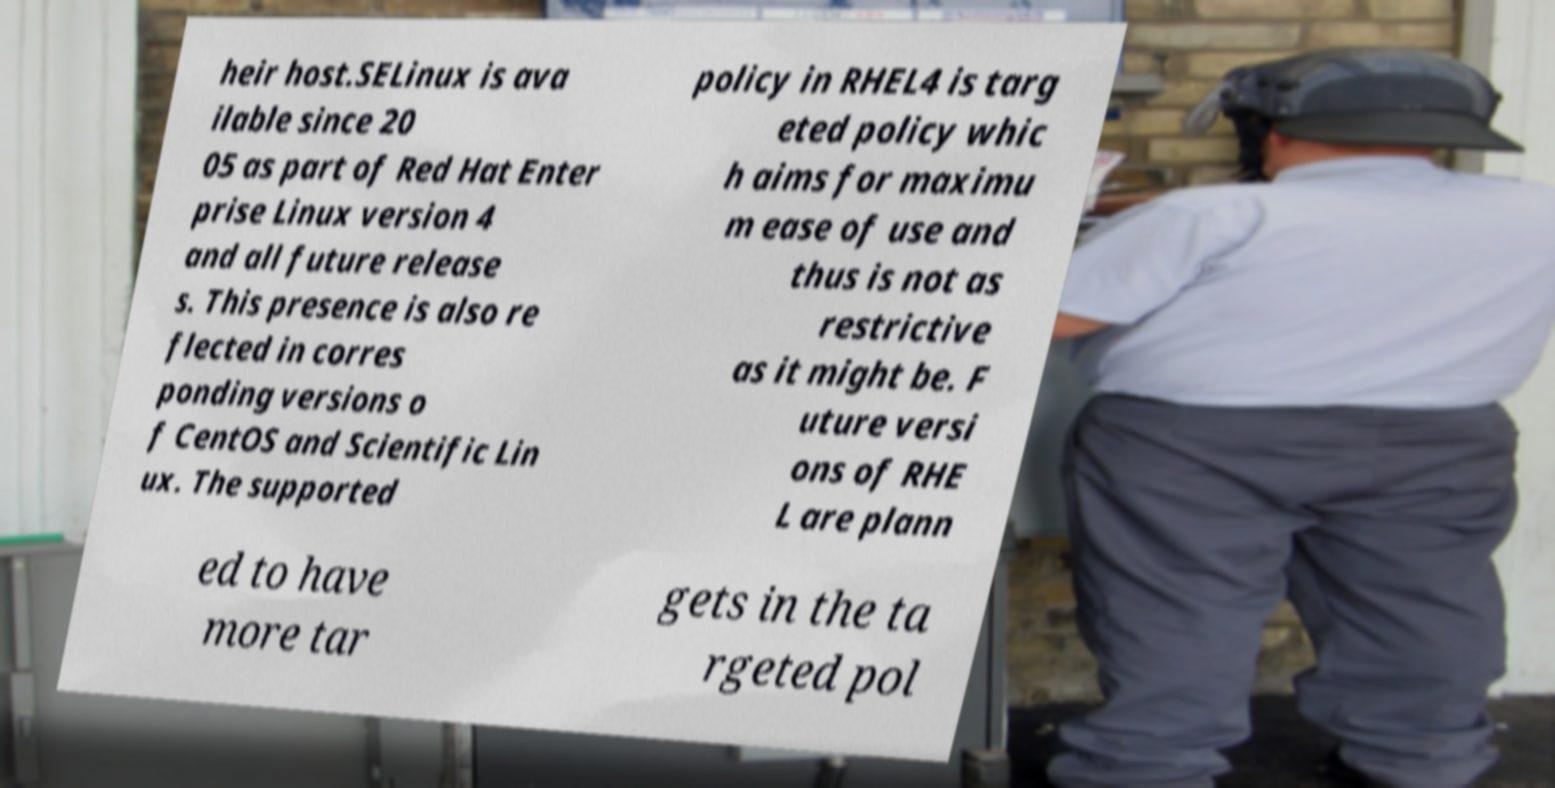Can you accurately transcribe the text from the provided image for me? heir host.SELinux is ava ilable since 20 05 as part of Red Hat Enter prise Linux version 4 and all future release s. This presence is also re flected in corres ponding versions o f CentOS and Scientific Lin ux. The supported policy in RHEL4 is targ eted policy whic h aims for maximu m ease of use and thus is not as restrictive as it might be. F uture versi ons of RHE L are plann ed to have more tar gets in the ta rgeted pol 